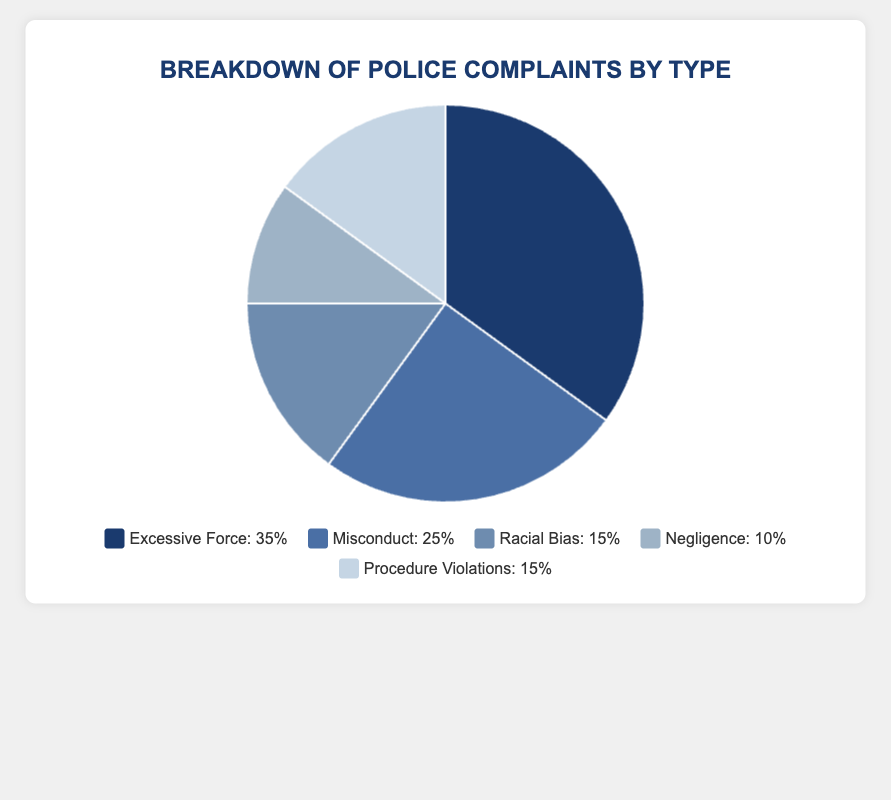What percentage of complaints are due to Misconduct and Negligence combined? To find the combined percentage, add the percentage for Misconduct (25%) and the percentage for Negligence (10%). So, 25% + 10% = 35%.
Answer: 35% Which type of complaint accounts for the highest percentage? The complaint type with the highest percentage is Excessive Force, which has a percentage of 35%.
Answer: Excessive Force How much greater is the percentage of Excessive Force complaints compared to Racial Bias complaints? Subtract the percentage of Racial Bias complaints (15%) from the percentage of Excessive Force complaints (35%). So, 35% - 15% = 20%.
Answer: 20% Are the percentages for Racial Bias and Procedure Violations equal? The figure shows that both Racial Bias and Procedure Violations have percentages of 15%. Since they are the same value, the answer is yes.
Answer: Yes What is the difference in percentage between the highest and lowest types of complaints? The highest percentage is for Excessive Force (35%) and the lowest is for Negligence (10%). Subtract the lowest from the highest: 35% - 10% = 25%.
Answer: 25% What fraction of complaints are due to Procedure Violations, if converted from percentage? The percentage of complaints due to Procedure Violations is 15%. To convert this to a fraction, 15% is equivalent to 15/100, which simplifies to 3/20.
Answer: 3/20 Compare the percentages for Misconduct and Excessive Force. Which one is greater and by how much? Excessive Force has a percentage of 35% and Misconduct has a percentage of 25%. Subtract the lower value from the higher one: 35% - 25% = 10%. Hence, Excessive Force is greater by 10%.
Answer: Excessive Force, by 10% Explain how you would calculate the average percentage for the complaints excluding the highest and lowest values. Excluding the highest (Excessive Force, 35%) and lowest (Negligence, 10%) values, the remaining percentages are 25% (Misconduct), 15% (Racial Bias), and 15% (Procedure Violations). First, sum these values: 25% + 15% + 15% = 55%. Then, divide by the number of values (3): 55% / 3 ≈ 18.33%.
Answer: 18.33% What color represents the Misconduct complaints in the chart? Based on the colors assigned for the complaints, Misconduct is the second item, so it is represented by the second color in the list. Referring to the provided colors, it is 'blue'.
Answer: Blue 